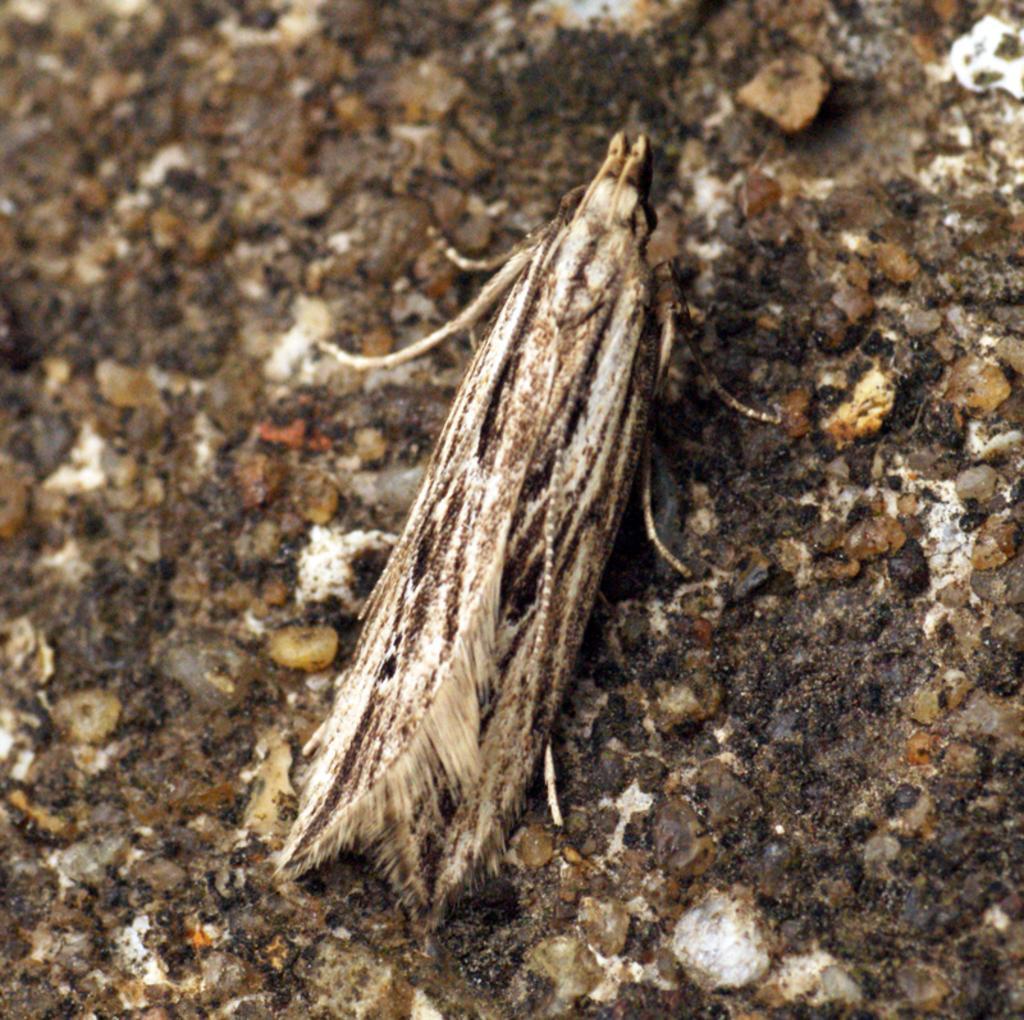Can you describe this image briefly? In this picture I can observe an insect. In the background I can observe small stones. 